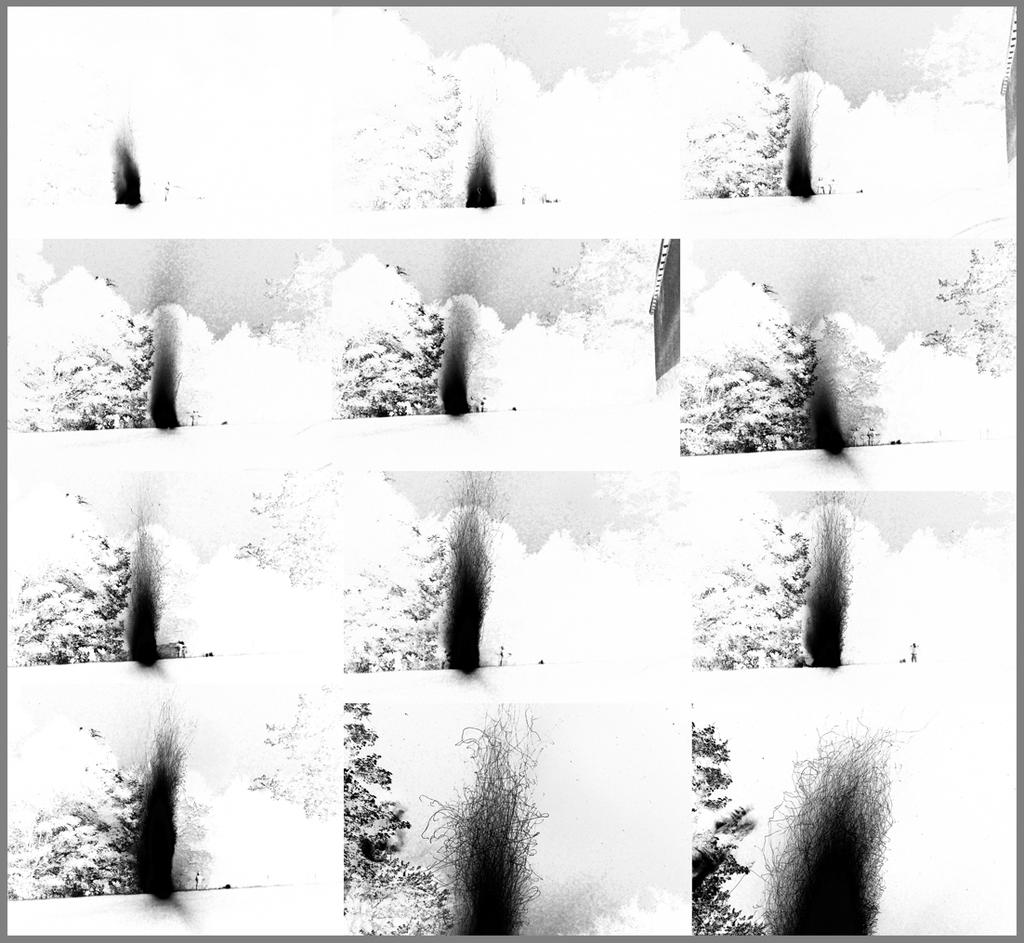What type of artwork is shown in the image? The image is a collage of pictures. Can you identify any specific elements within the collage? Yes, there are trees present in the collage of pictures. What type of lumber is being used to build the government building in the image? There is no government building or lumber present in the image; it is a collage of pictures featuring trees. 